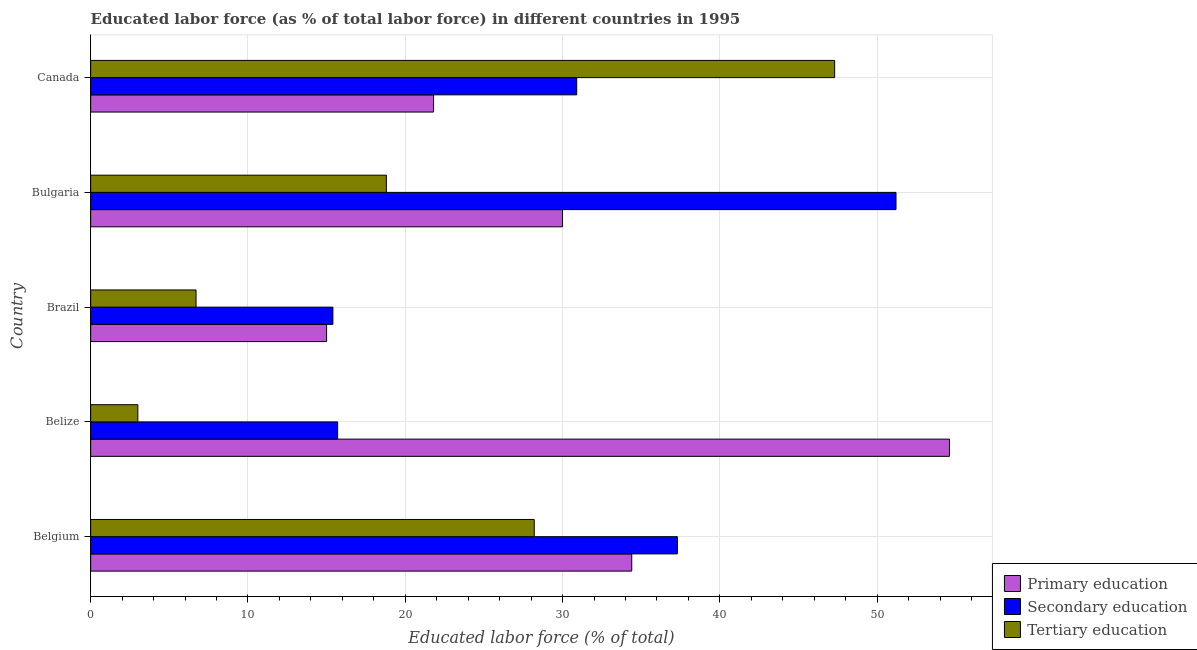How many different coloured bars are there?
Ensure brevity in your answer.  3. Are the number of bars per tick equal to the number of legend labels?
Your answer should be compact. Yes. How many bars are there on the 1st tick from the top?
Make the answer very short. 3. How many bars are there on the 1st tick from the bottom?
Keep it short and to the point. 3. What is the label of the 2nd group of bars from the top?
Provide a short and direct response. Bulgaria. In how many cases, is the number of bars for a given country not equal to the number of legend labels?
Keep it short and to the point. 0. What is the percentage of labor force who received primary education in Belgium?
Offer a terse response. 34.4. Across all countries, what is the maximum percentage of labor force who received primary education?
Your response must be concise. 54.6. Across all countries, what is the minimum percentage of labor force who received secondary education?
Your answer should be very brief. 15.4. In which country was the percentage of labor force who received tertiary education maximum?
Make the answer very short. Canada. What is the total percentage of labor force who received tertiary education in the graph?
Your response must be concise. 104. What is the difference between the percentage of labor force who received primary education in Belgium and that in Brazil?
Make the answer very short. 19.4. What is the difference between the percentage of labor force who received primary education in Bulgaria and the percentage of labor force who received tertiary education in Belgium?
Offer a terse response. 1.8. What is the average percentage of labor force who received tertiary education per country?
Your answer should be compact. 20.8. What is the difference between the percentage of labor force who received primary education and percentage of labor force who received tertiary education in Belize?
Offer a very short reply. 51.6. What is the difference between the highest and the lowest percentage of labor force who received primary education?
Ensure brevity in your answer.  39.6. What does the 1st bar from the top in Canada represents?
Make the answer very short. Tertiary education. What does the 3rd bar from the bottom in Belize represents?
Ensure brevity in your answer.  Tertiary education. How many countries are there in the graph?
Provide a short and direct response. 5. What is the difference between two consecutive major ticks on the X-axis?
Keep it short and to the point. 10. Does the graph contain grids?
Ensure brevity in your answer.  Yes. Where does the legend appear in the graph?
Make the answer very short. Bottom right. How many legend labels are there?
Make the answer very short. 3. How are the legend labels stacked?
Ensure brevity in your answer.  Vertical. What is the title of the graph?
Make the answer very short. Educated labor force (as % of total labor force) in different countries in 1995. What is the label or title of the X-axis?
Keep it short and to the point. Educated labor force (% of total). What is the label or title of the Y-axis?
Provide a succinct answer. Country. What is the Educated labor force (% of total) of Primary education in Belgium?
Keep it short and to the point. 34.4. What is the Educated labor force (% of total) of Secondary education in Belgium?
Provide a short and direct response. 37.3. What is the Educated labor force (% of total) in Tertiary education in Belgium?
Offer a terse response. 28.2. What is the Educated labor force (% of total) in Primary education in Belize?
Your answer should be compact. 54.6. What is the Educated labor force (% of total) of Secondary education in Belize?
Your answer should be compact. 15.7. What is the Educated labor force (% of total) of Secondary education in Brazil?
Your response must be concise. 15.4. What is the Educated labor force (% of total) of Tertiary education in Brazil?
Ensure brevity in your answer.  6.7. What is the Educated labor force (% of total) of Primary education in Bulgaria?
Keep it short and to the point. 30. What is the Educated labor force (% of total) of Secondary education in Bulgaria?
Provide a short and direct response. 51.2. What is the Educated labor force (% of total) of Tertiary education in Bulgaria?
Provide a succinct answer. 18.8. What is the Educated labor force (% of total) in Primary education in Canada?
Provide a succinct answer. 21.8. What is the Educated labor force (% of total) in Secondary education in Canada?
Keep it short and to the point. 30.9. What is the Educated labor force (% of total) of Tertiary education in Canada?
Your answer should be compact. 47.3. Across all countries, what is the maximum Educated labor force (% of total) in Primary education?
Your response must be concise. 54.6. Across all countries, what is the maximum Educated labor force (% of total) in Secondary education?
Give a very brief answer. 51.2. Across all countries, what is the maximum Educated labor force (% of total) of Tertiary education?
Your response must be concise. 47.3. Across all countries, what is the minimum Educated labor force (% of total) of Secondary education?
Your response must be concise. 15.4. What is the total Educated labor force (% of total) in Primary education in the graph?
Give a very brief answer. 155.8. What is the total Educated labor force (% of total) of Secondary education in the graph?
Your answer should be compact. 150.5. What is the total Educated labor force (% of total) in Tertiary education in the graph?
Offer a very short reply. 104. What is the difference between the Educated labor force (% of total) of Primary education in Belgium and that in Belize?
Make the answer very short. -20.2. What is the difference between the Educated labor force (% of total) in Secondary education in Belgium and that in Belize?
Make the answer very short. 21.6. What is the difference between the Educated labor force (% of total) of Tertiary education in Belgium and that in Belize?
Give a very brief answer. 25.2. What is the difference between the Educated labor force (% of total) in Secondary education in Belgium and that in Brazil?
Offer a terse response. 21.9. What is the difference between the Educated labor force (% of total) of Primary education in Belgium and that in Bulgaria?
Provide a short and direct response. 4.4. What is the difference between the Educated labor force (% of total) of Secondary education in Belgium and that in Bulgaria?
Your answer should be compact. -13.9. What is the difference between the Educated labor force (% of total) in Primary education in Belgium and that in Canada?
Keep it short and to the point. 12.6. What is the difference between the Educated labor force (% of total) of Secondary education in Belgium and that in Canada?
Offer a very short reply. 6.4. What is the difference between the Educated labor force (% of total) in Tertiary education in Belgium and that in Canada?
Provide a succinct answer. -19.1. What is the difference between the Educated labor force (% of total) of Primary education in Belize and that in Brazil?
Give a very brief answer. 39.6. What is the difference between the Educated labor force (% of total) of Tertiary education in Belize and that in Brazil?
Keep it short and to the point. -3.7. What is the difference between the Educated labor force (% of total) in Primary education in Belize and that in Bulgaria?
Your answer should be compact. 24.6. What is the difference between the Educated labor force (% of total) in Secondary education in Belize and that in Bulgaria?
Ensure brevity in your answer.  -35.5. What is the difference between the Educated labor force (% of total) in Tertiary education in Belize and that in Bulgaria?
Offer a terse response. -15.8. What is the difference between the Educated labor force (% of total) in Primary education in Belize and that in Canada?
Offer a terse response. 32.8. What is the difference between the Educated labor force (% of total) in Secondary education in Belize and that in Canada?
Provide a succinct answer. -15.2. What is the difference between the Educated labor force (% of total) of Tertiary education in Belize and that in Canada?
Your response must be concise. -44.3. What is the difference between the Educated labor force (% of total) in Primary education in Brazil and that in Bulgaria?
Your answer should be compact. -15. What is the difference between the Educated labor force (% of total) of Secondary education in Brazil and that in Bulgaria?
Your answer should be very brief. -35.8. What is the difference between the Educated labor force (% of total) in Tertiary education in Brazil and that in Bulgaria?
Provide a succinct answer. -12.1. What is the difference between the Educated labor force (% of total) of Primary education in Brazil and that in Canada?
Make the answer very short. -6.8. What is the difference between the Educated labor force (% of total) of Secondary education in Brazil and that in Canada?
Offer a terse response. -15.5. What is the difference between the Educated labor force (% of total) in Tertiary education in Brazil and that in Canada?
Offer a terse response. -40.6. What is the difference between the Educated labor force (% of total) in Secondary education in Bulgaria and that in Canada?
Ensure brevity in your answer.  20.3. What is the difference between the Educated labor force (% of total) of Tertiary education in Bulgaria and that in Canada?
Keep it short and to the point. -28.5. What is the difference between the Educated labor force (% of total) of Primary education in Belgium and the Educated labor force (% of total) of Tertiary education in Belize?
Provide a short and direct response. 31.4. What is the difference between the Educated labor force (% of total) in Secondary education in Belgium and the Educated labor force (% of total) in Tertiary education in Belize?
Offer a very short reply. 34.3. What is the difference between the Educated labor force (% of total) of Primary education in Belgium and the Educated labor force (% of total) of Secondary education in Brazil?
Give a very brief answer. 19. What is the difference between the Educated labor force (% of total) in Primary education in Belgium and the Educated labor force (% of total) in Tertiary education in Brazil?
Provide a short and direct response. 27.7. What is the difference between the Educated labor force (% of total) in Secondary education in Belgium and the Educated labor force (% of total) in Tertiary education in Brazil?
Make the answer very short. 30.6. What is the difference between the Educated labor force (% of total) of Primary education in Belgium and the Educated labor force (% of total) of Secondary education in Bulgaria?
Offer a very short reply. -16.8. What is the difference between the Educated labor force (% of total) of Secondary education in Belgium and the Educated labor force (% of total) of Tertiary education in Canada?
Provide a short and direct response. -10. What is the difference between the Educated labor force (% of total) in Primary education in Belize and the Educated labor force (% of total) in Secondary education in Brazil?
Your answer should be compact. 39.2. What is the difference between the Educated labor force (% of total) in Primary education in Belize and the Educated labor force (% of total) in Tertiary education in Brazil?
Ensure brevity in your answer.  47.9. What is the difference between the Educated labor force (% of total) of Secondary education in Belize and the Educated labor force (% of total) of Tertiary education in Brazil?
Give a very brief answer. 9. What is the difference between the Educated labor force (% of total) of Primary education in Belize and the Educated labor force (% of total) of Tertiary education in Bulgaria?
Your answer should be compact. 35.8. What is the difference between the Educated labor force (% of total) of Secondary education in Belize and the Educated labor force (% of total) of Tertiary education in Bulgaria?
Provide a succinct answer. -3.1. What is the difference between the Educated labor force (% of total) of Primary education in Belize and the Educated labor force (% of total) of Secondary education in Canada?
Ensure brevity in your answer.  23.7. What is the difference between the Educated labor force (% of total) of Secondary education in Belize and the Educated labor force (% of total) of Tertiary education in Canada?
Give a very brief answer. -31.6. What is the difference between the Educated labor force (% of total) of Primary education in Brazil and the Educated labor force (% of total) of Secondary education in Bulgaria?
Make the answer very short. -36.2. What is the difference between the Educated labor force (% of total) in Primary education in Brazil and the Educated labor force (% of total) in Secondary education in Canada?
Your response must be concise. -15.9. What is the difference between the Educated labor force (% of total) of Primary education in Brazil and the Educated labor force (% of total) of Tertiary education in Canada?
Provide a short and direct response. -32.3. What is the difference between the Educated labor force (% of total) of Secondary education in Brazil and the Educated labor force (% of total) of Tertiary education in Canada?
Your answer should be very brief. -31.9. What is the difference between the Educated labor force (% of total) in Primary education in Bulgaria and the Educated labor force (% of total) in Secondary education in Canada?
Provide a succinct answer. -0.9. What is the difference between the Educated labor force (% of total) of Primary education in Bulgaria and the Educated labor force (% of total) of Tertiary education in Canada?
Your answer should be compact. -17.3. What is the average Educated labor force (% of total) in Primary education per country?
Your answer should be compact. 31.16. What is the average Educated labor force (% of total) of Secondary education per country?
Your response must be concise. 30.1. What is the average Educated labor force (% of total) of Tertiary education per country?
Offer a terse response. 20.8. What is the difference between the Educated labor force (% of total) in Primary education and Educated labor force (% of total) in Secondary education in Belgium?
Keep it short and to the point. -2.9. What is the difference between the Educated labor force (% of total) in Secondary education and Educated labor force (% of total) in Tertiary education in Belgium?
Your response must be concise. 9.1. What is the difference between the Educated labor force (% of total) in Primary education and Educated labor force (% of total) in Secondary education in Belize?
Provide a succinct answer. 38.9. What is the difference between the Educated labor force (% of total) in Primary education and Educated labor force (% of total) in Tertiary education in Belize?
Offer a very short reply. 51.6. What is the difference between the Educated labor force (% of total) of Primary education and Educated labor force (% of total) of Tertiary education in Brazil?
Ensure brevity in your answer.  8.3. What is the difference between the Educated labor force (% of total) of Primary education and Educated labor force (% of total) of Secondary education in Bulgaria?
Provide a succinct answer. -21.2. What is the difference between the Educated labor force (% of total) in Primary education and Educated labor force (% of total) in Tertiary education in Bulgaria?
Offer a very short reply. 11.2. What is the difference between the Educated labor force (% of total) of Secondary education and Educated labor force (% of total) of Tertiary education in Bulgaria?
Offer a very short reply. 32.4. What is the difference between the Educated labor force (% of total) of Primary education and Educated labor force (% of total) of Tertiary education in Canada?
Offer a very short reply. -25.5. What is the difference between the Educated labor force (% of total) in Secondary education and Educated labor force (% of total) in Tertiary education in Canada?
Offer a very short reply. -16.4. What is the ratio of the Educated labor force (% of total) in Primary education in Belgium to that in Belize?
Offer a terse response. 0.63. What is the ratio of the Educated labor force (% of total) of Secondary education in Belgium to that in Belize?
Give a very brief answer. 2.38. What is the ratio of the Educated labor force (% of total) of Tertiary education in Belgium to that in Belize?
Make the answer very short. 9.4. What is the ratio of the Educated labor force (% of total) of Primary education in Belgium to that in Brazil?
Offer a terse response. 2.29. What is the ratio of the Educated labor force (% of total) of Secondary education in Belgium to that in Brazil?
Ensure brevity in your answer.  2.42. What is the ratio of the Educated labor force (% of total) in Tertiary education in Belgium to that in Brazil?
Keep it short and to the point. 4.21. What is the ratio of the Educated labor force (% of total) of Primary education in Belgium to that in Bulgaria?
Your answer should be very brief. 1.15. What is the ratio of the Educated labor force (% of total) of Secondary education in Belgium to that in Bulgaria?
Ensure brevity in your answer.  0.73. What is the ratio of the Educated labor force (% of total) in Tertiary education in Belgium to that in Bulgaria?
Give a very brief answer. 1.5. What is the ratio of the Educated labor force (% of total) of Primary education in Belgium to that in Canada?
Make the answer very short. 1.58. What is the ratio of the Educated labor force (% of total) in Secondary education in Belgium to that in Canada?
Your answer should be very brief. 1.21. What is the ratio of the Educated labor force (% of total) of Tertiary education in Belgium to that in Canada?
Offer a terse response. 0.6. What is the ratio of the Educated labor force (% of total) of Primary education in Belize to that in Brazil?
Make the answer very short. 3.64. What is the ratio of the Educated labor force (% of total) in Secondary education in Belize to that in Brazil?
Keep it short and to the point. 1.02. What is the ratio of the Educated labor force (% of total) of Tertiary education in Belize to that in Brazil?
Provide a succinct answer. 0.45. What is the ratio of the Educated labor force (% of total) in Primary education in Belize to that in Bulgaria?
Your answer should be compact. 1.82. What is the ratio of the Educated labor force (% of total) in Secondary education in Belize to that in Bulgaria?
Your answer should be compact. 0.31. What is the ratio of the Educated labor force (% of total) of Tertiary education in Belize to that in Bulgaria?
Provide a short and direct response. 0.16. What is the ratio of the Educated labor force (% of total) of Primary education in Belize to that in Canada?
Offer a terse response. 2.5. What is the ratio of the Educated labor force (% of total) in Secondary education in Belize to that in Canada?
Ensure brevity in your answer.  0.51. What is the ratio of the Educated labor force (% of total) of Tertiary education in Belize to that in Canada?
Offer a terse response. 0.06. What is the ratio of the Educated labor force (% of total) in Secondary education in Brazil to that in Bulgaria?
Your answer should be very brief. 0.3. What is the ratio of the Educated labor force (% of total) of Tertiary education in Brazil to that in Bulgaria?
Make the answer very short. 0.36. What is the ratio of the Educated labor force (% of total) of Primary education in Brazil to that in Canada?
Keep it short and to the point. 0.69. What is the ratio of the Educated labor force (% of total) of Secondary education in Brazil to that in Canada?
Keep it short and to the point. 0.5. What is the ratio of the Educated labor force (% of total) of Tertiary education in Brazil to that in Canada?
Ensure brevity in your answer.  0.14. What is the ratio of the Educated labor force (% of total) of Primary education in Bulgaria to that in Canada?
Make the answer very short. 1.38. What is the ratio of the Educated labor force (% of total) of Secondary education in Bulgaria to that in Canada?
Your response must be concise. 1.66. What is the ratio of the Educated labor force (% of total) in Tertiary education in Bulgaria to that in Canada?
Keep it short and to the point. 0.4. What is the difference between the highest and the second highest Educated labor force (% of total) of Primary education?
Your answer should be compact. 20.2. What is the difference between the highest and the second highest Educated labor force (% of total) of Secondary education?
Give a very brief answer. 13.9. What is the difference between the highest and the second highest Educated labor force (% of total) in Tertiary education?
Keep it short and to the point. 19.1. What is the difference between the highest and the lowest Educated labor force (% of total) in Primary education?
Provide a short and direct response. 39.6. What is the difference between the highest and the lowest Educated labor force (% of total) in Secondary education?
Your response must be concise. 35.8. What is the difference between the highest and the lowest Educated labor force (% of total) of Tertiary education?
Offer a terse response. 44.3. 